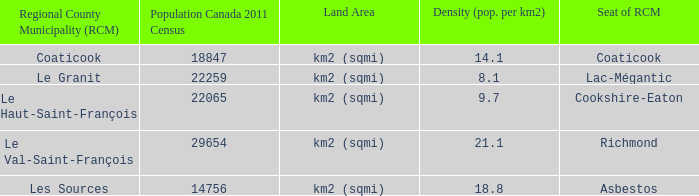What is the land coverage of the rcm that has a density of 2 Km2 (sqmi). 